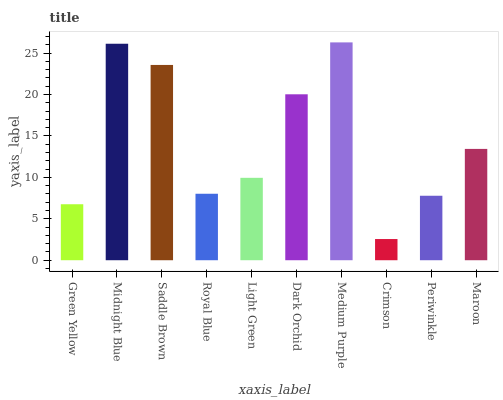Is Crimson the minimum?
Answer yes or no. Yes. Is Medium Purple the maximum?
Answer yes or no. Yes. Is Midnight Blue the minimum?
Answer yes or no. No. Is Midnight Blue the maximum?
Answer yes or no. No. Is Midnight Blue greater than Green Yellow?
Answer yes or no. Yes. Is Green Yellow less than Midnight Blue?
Answer yes or no. Yes. Is Green Yellow greater than Midnight Blue?
Answer yes or no. No. Is Midnight Blue less than Green Yellow?
Answer yes or no. No. Is Maroon the high median?
Answer yes or no. Yes. Is Light Green the low median?
Answer yes or no. Yes. Is Light Green the high median?
Answer yes or no. No. Is Midnight Blue the low median?
Answer yes or no. No. 